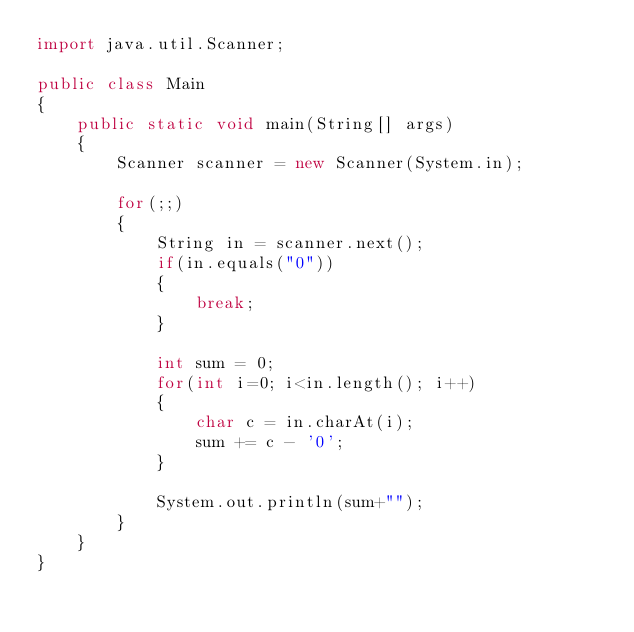Convert code to text. <code><loc_0><loc_0><loc_500><loc_500><_Java_>import java.util.Scanner;

public class Main 
{
	public static void main(String[] args)
	{
		Scanner scanner = new Scanner(System.in);
		
		for(;;)
		{
			String in = scanner.next();
			if(in.equals("0"))
			{
				break;
			}
			
			int sum = 0;
			for(int i=0; i<in.length(); i++)
			{
				char c = in.charAt(i);
				sum += c - '0';
			}
			
			System.out.println(sum+"");
		}
	}
}</code> 